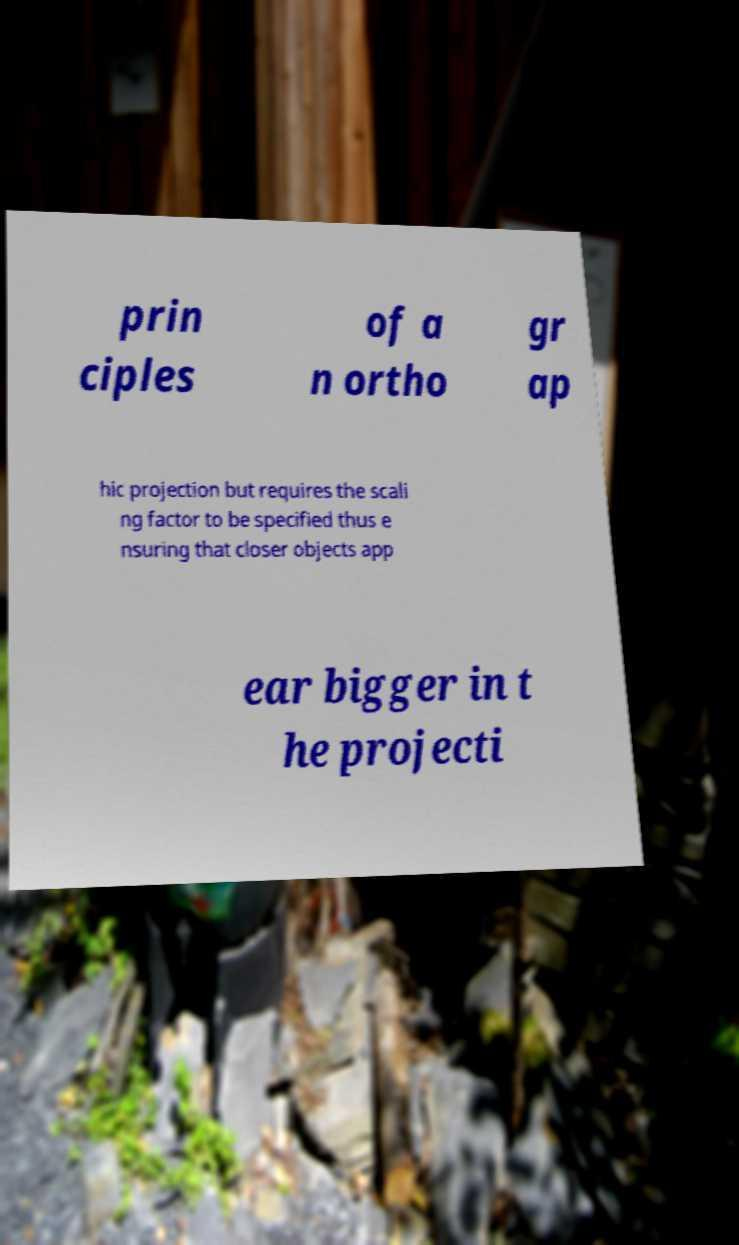What messages or text are displayed in this image? I need them in a readable, typed format. prin ciples of a n ortho gr ap hic projection but requires the scali ng factor to be specified thus e nsuring that closer objects app ear bigger in t he projecti 